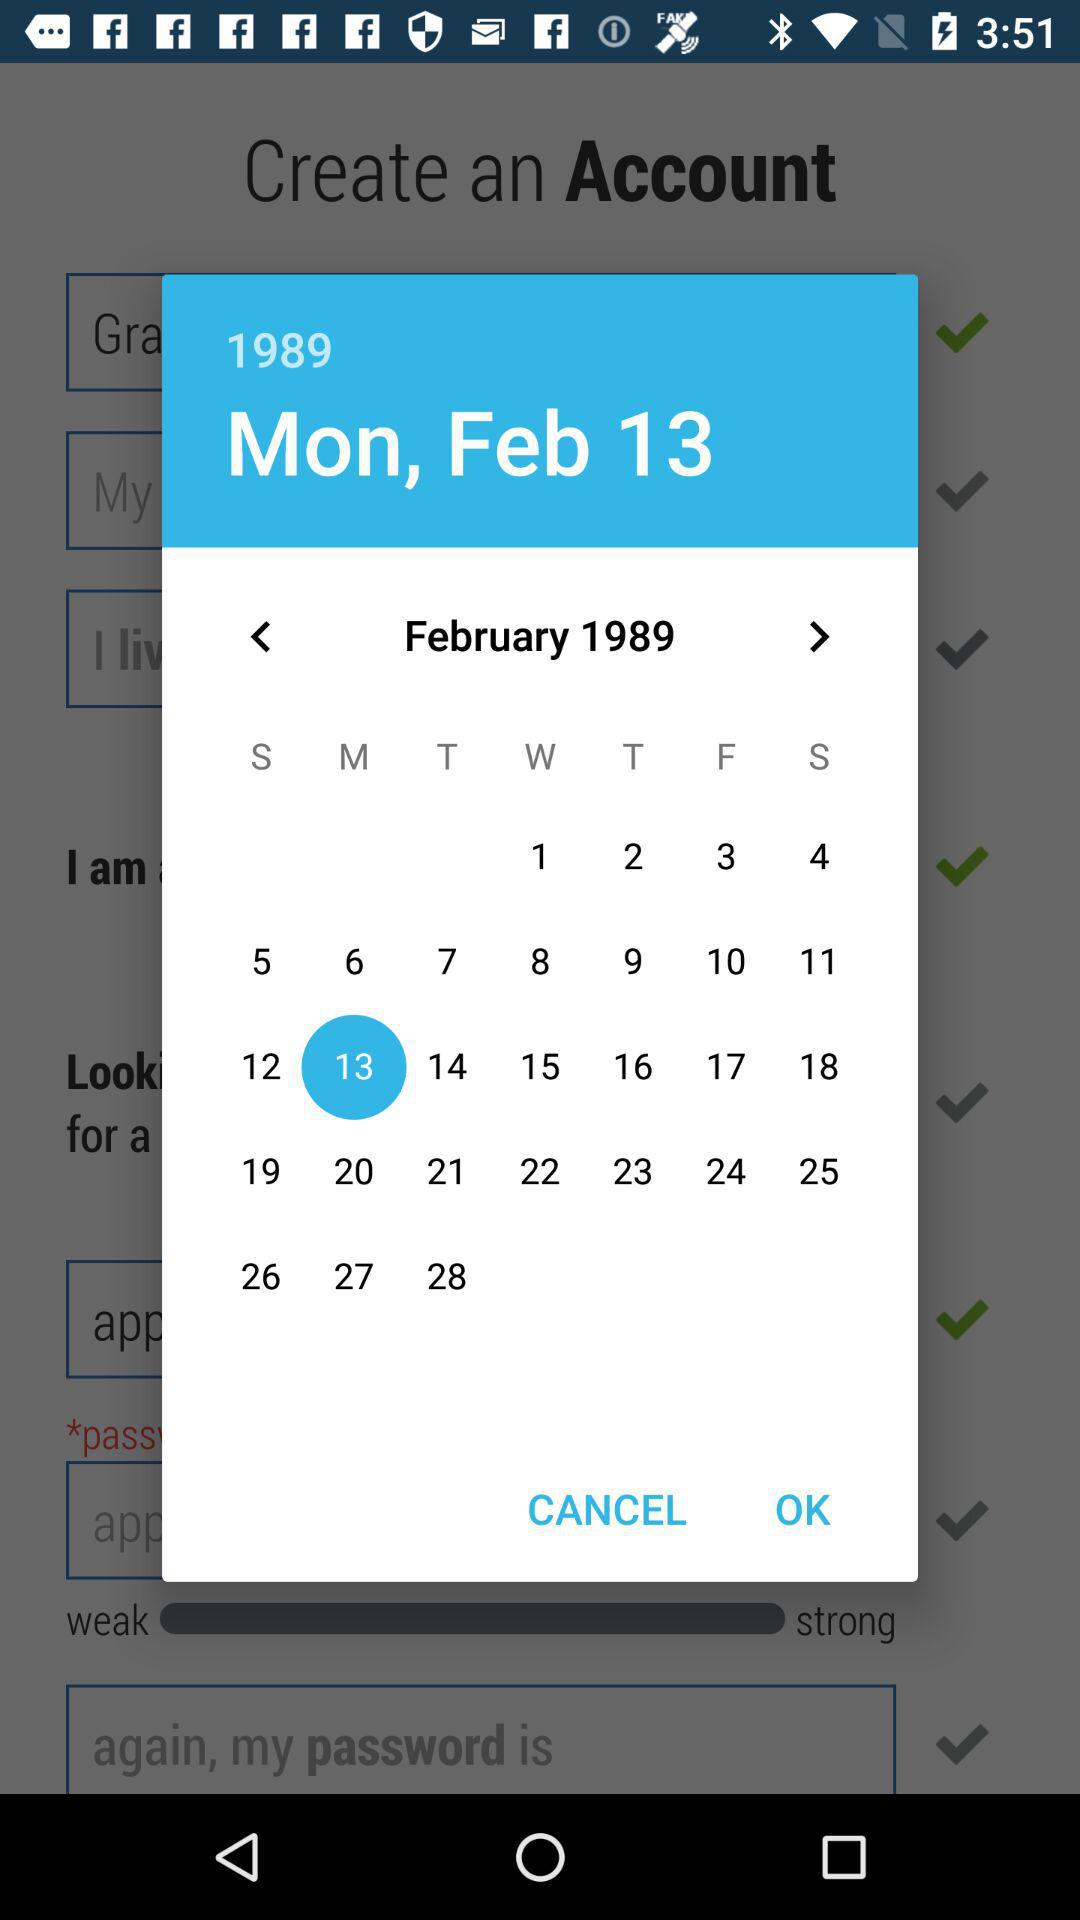What is the selected date? The selected date is Monday, February 13, 1989. 